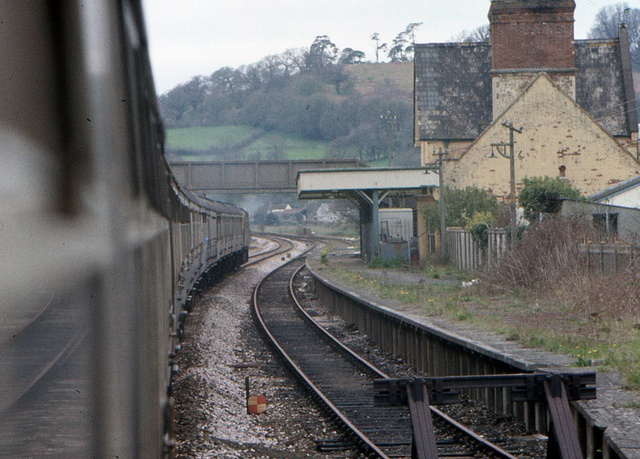Describe the objects in this image and their specific colors. I can see a train in gray and black tones in this image. 